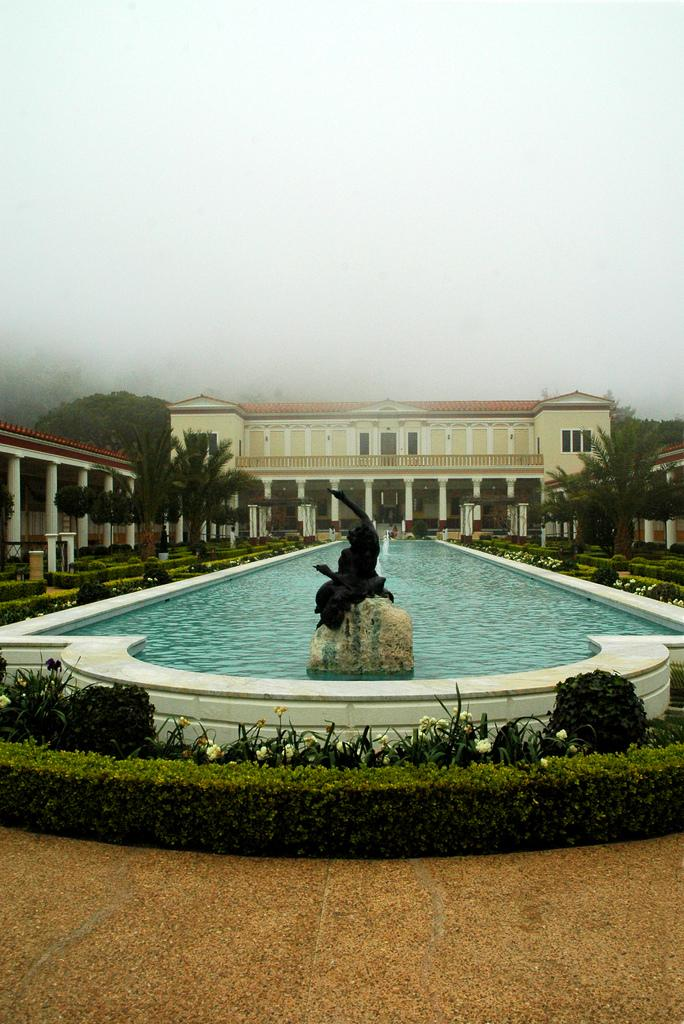What is the main structure in the center of the image? There is a building in the center of the image. What can be seen at the bottom of the image? At the bottom of the image, there is a hedge, shrubs, a statue, and a fountain. What is visible in the background of the image? There are trees and the sky visible in the background of the image. How much debt is represented by the statue in the image? There is no indication of debt in the image, and the statue does not represent any financial concept. 